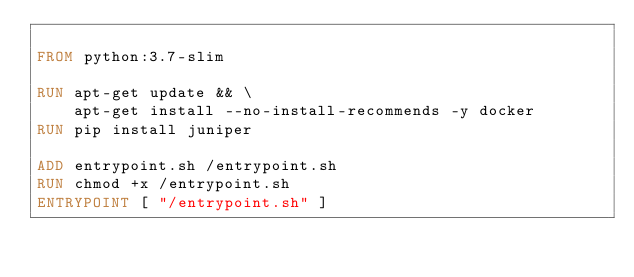Convert code to text. <code><loc_0><loc_0><loc_500><loc_500><_Dockerfile_>  
FROM python:3.7-slim

RUN apt-get update && \
    apt-get install --no-install-recommends -y docker
RUN pip install juniper

ADD entrypoint.sh /entrypoint.sh
RUN chmod +x /entrypoint.sh
ENTRYPOINT [ "/entrypoint.sh" ]
</code> 